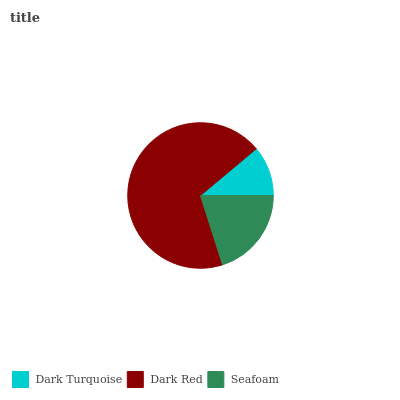Is Dark Turquoise the minimum?
Answer yes or no. Yes. Is Dark Red the maximum?
Answer yes or no. Yes. Is Seafoam the minimum?
Answer yes or no. No. Is Seafoam the maximum?
Answer yes or no. No. Is Dark Red greater than Seafoam?
Answer yes or no. Yes. Is Seafoam less than Dark Red?
Answer yes or no. Yes. Is Seafoam greater than Dark Red?
Answer yes or no. No. Is Dark Red less than Seafoam?
Answer yes or no. No. Is Seafoam the high median?
Answer yes or no. Yes. Is Seafoam the low median?
Answer yes or no. Yes. Is Dark Red the high median?
Answer yes or no. No. Is Dark Turquoise the low median?
Answer yes or no. No. 